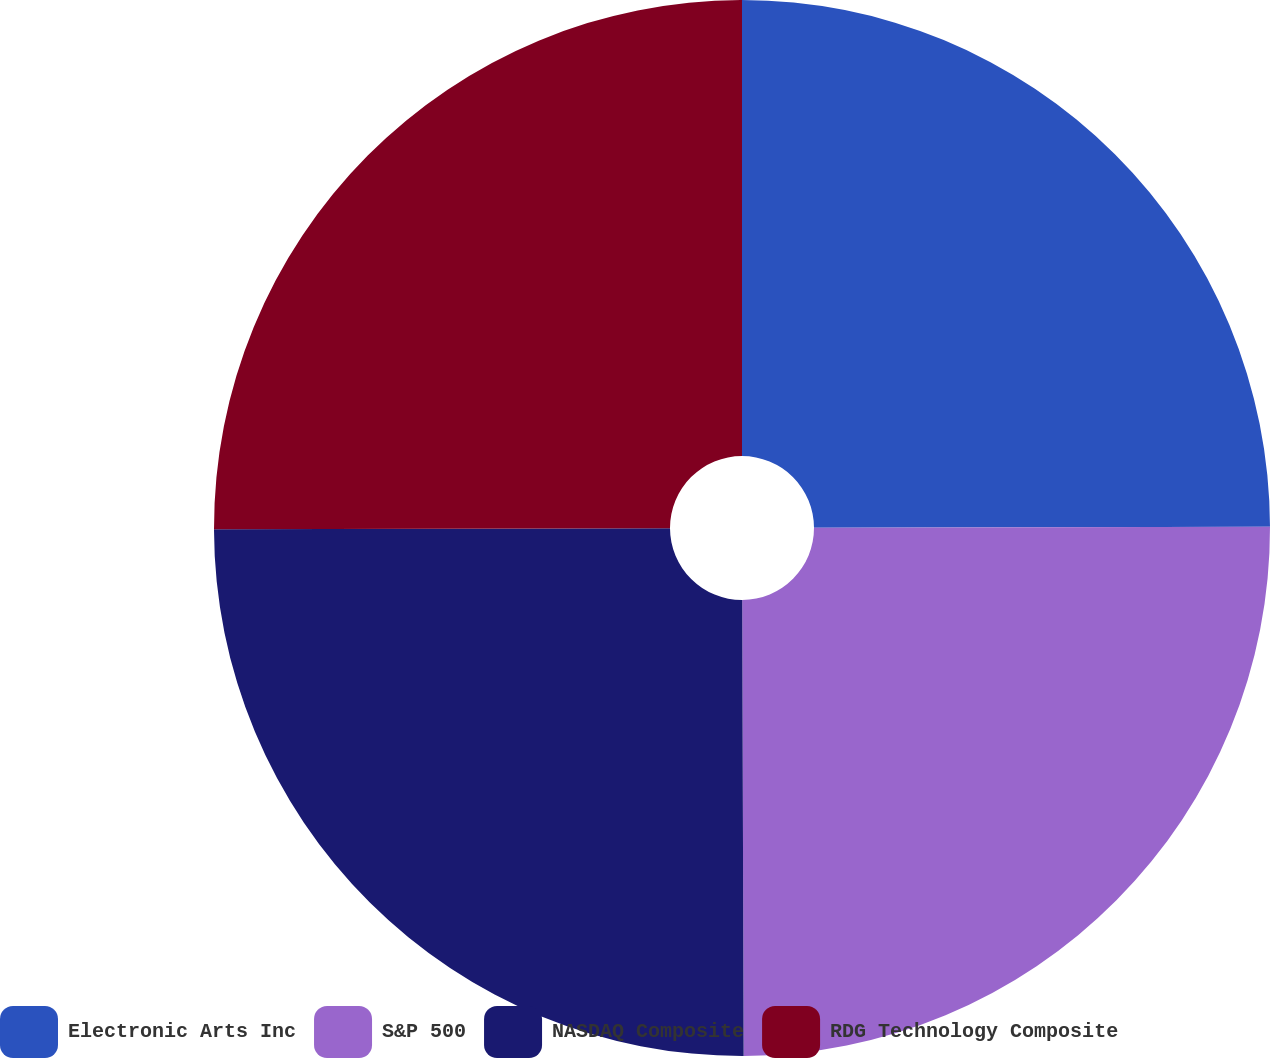<chart> <loc_0><loc_0><loc_500><loc_500><pie_chart><fcel>Electronic Arts Inc<fcel>S&P 500<fcel>NASDAQ Composite<fcel>RDG Technology Composite<nl><fcel>24.96%<fcel>24.99%<fcel>25.01%<fcel>25.04%<nl></chart> 